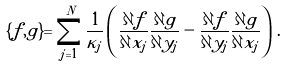<formula> <loc_0><loc_0><loc_500><loc_500>\{ f , g \} = \sum ^ { N } _ { j = 1 } \frac { 1 } { \kappa _ { j } } \left ( \frac { \partial f } { \partial x _ { j } } \frac { \partial g } { \partial y _ { j } } - \frac { \partial f } { \partial y _ { j } } \frac { \partial g } { \partial x _ { j } } \right ) \, .</formula> 